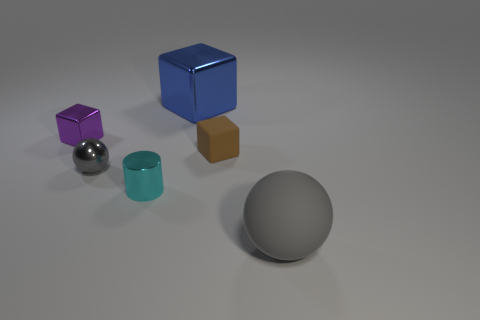Subtract all tiny blocks. How many blocks are left? 1 Subtract 1 blocks. How many blocks are left? 2 Add 3 small red balls. How many objects exist? 9 Subtract all blue blocks. How many blocks are left? 2 Subtract all yellow blocks. Subtract all brown cylinders. How many blocks are left? 3 Subtract all brown spheres. How many blue cubes are left? 1 Subtract all small gray things. Subtract all big blue metallic things. How many objects are left? 4 Add 2 big rubber objects. How many big rubber objects are left? 3 Add 2 small purple shiny things. How many small purple shiny things exist? 3 Subtract 0 brown spheres. How many objects are left? 6 